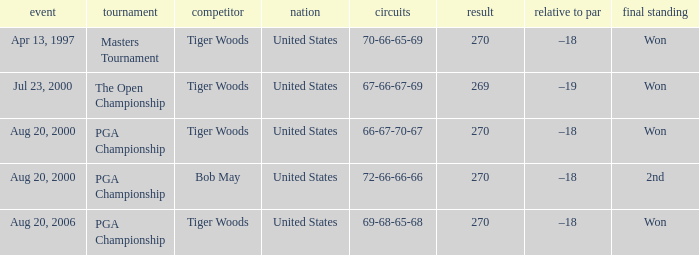What players finished 2nd? Bob May. 